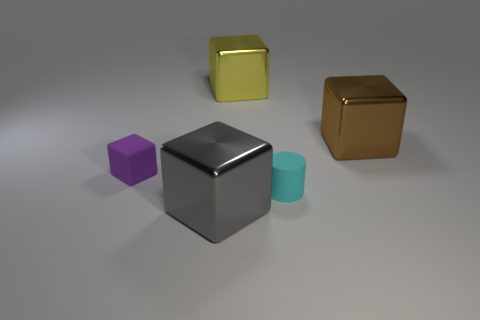There is a big block that is behind the large brown shiny object; what material is it?
Provide a short and direct response. Metal. What is the color of the shiny thing that is both to the left of the big brown block and behind the tiny purple thing?
Ensure brevity in your answer.  Yellow. What number of other objects are the same color as the small rubber cube?
Make the answer very short. 0. What color is the large metallic thing in front of the cylinder?
Ensure brevity in your answer.  Gray. Are there any other cyan matte things that have the same size as the cyan object?
Your answer should be very brief. No. What material is the cyan cylinder that is the same size as the rubber cube?
Provide a short and direct response. Rubber. How many objects are metal cubes behind the big brown shiny cube or things that are to the right of the big gray metal block?
Provide a short and direct response. 3. Is there a gray object that has the same shape as the tiny purple thing?
Your response must be concise. Yes. What number of shiny objects are either big brown things or large cubes?
Offer a terse response. 3. There is a gray shiny object; what shape is it?
Give a very brief answer. Cube. 